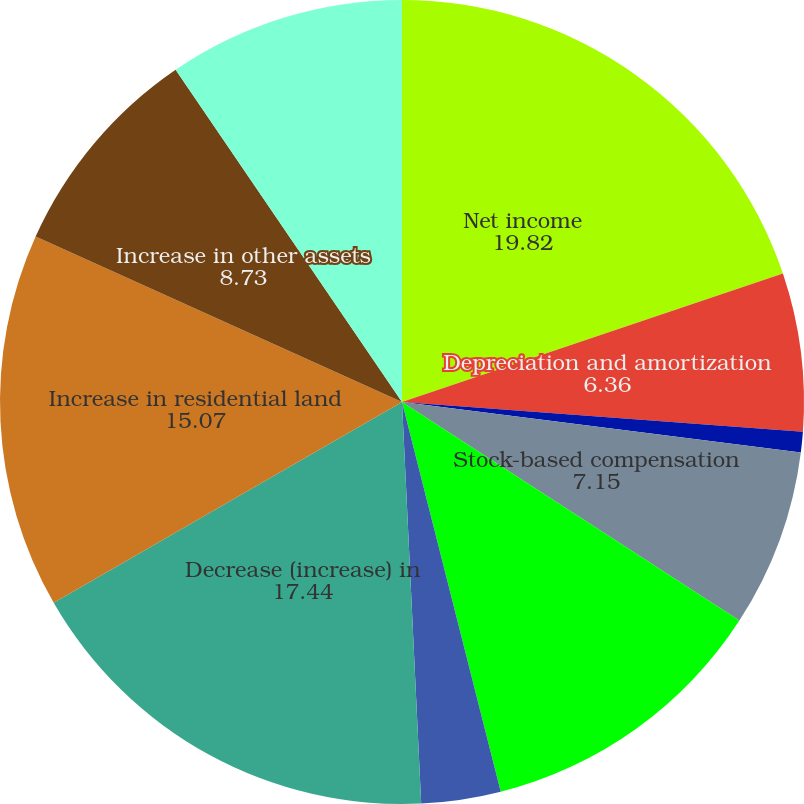Convert chart. <chart><loc_0><loc_0><loc_500><loc_500><pie_chart><fcel>Net income<fcel>Depreciation and amortization<fcel>Amortization of discounts and<fcel>Stock-based compensation<fcel>Deferred income taxes<fcel>Inventory and land option<fcel>Decrease (increase) in<fcel>Increase in residential land<fcel>Increase in other assets<fcel>Net (increase) decrease in<nl><fcel>19.82%<fcel>6.36%<fcel>0.82%<fcel>7.15%<fcel>11.9%<fcel>3.19%<fcel>17.44%<fcel>15.07%<fcel>8.73%<fcel>9.52%<nl></chart> 